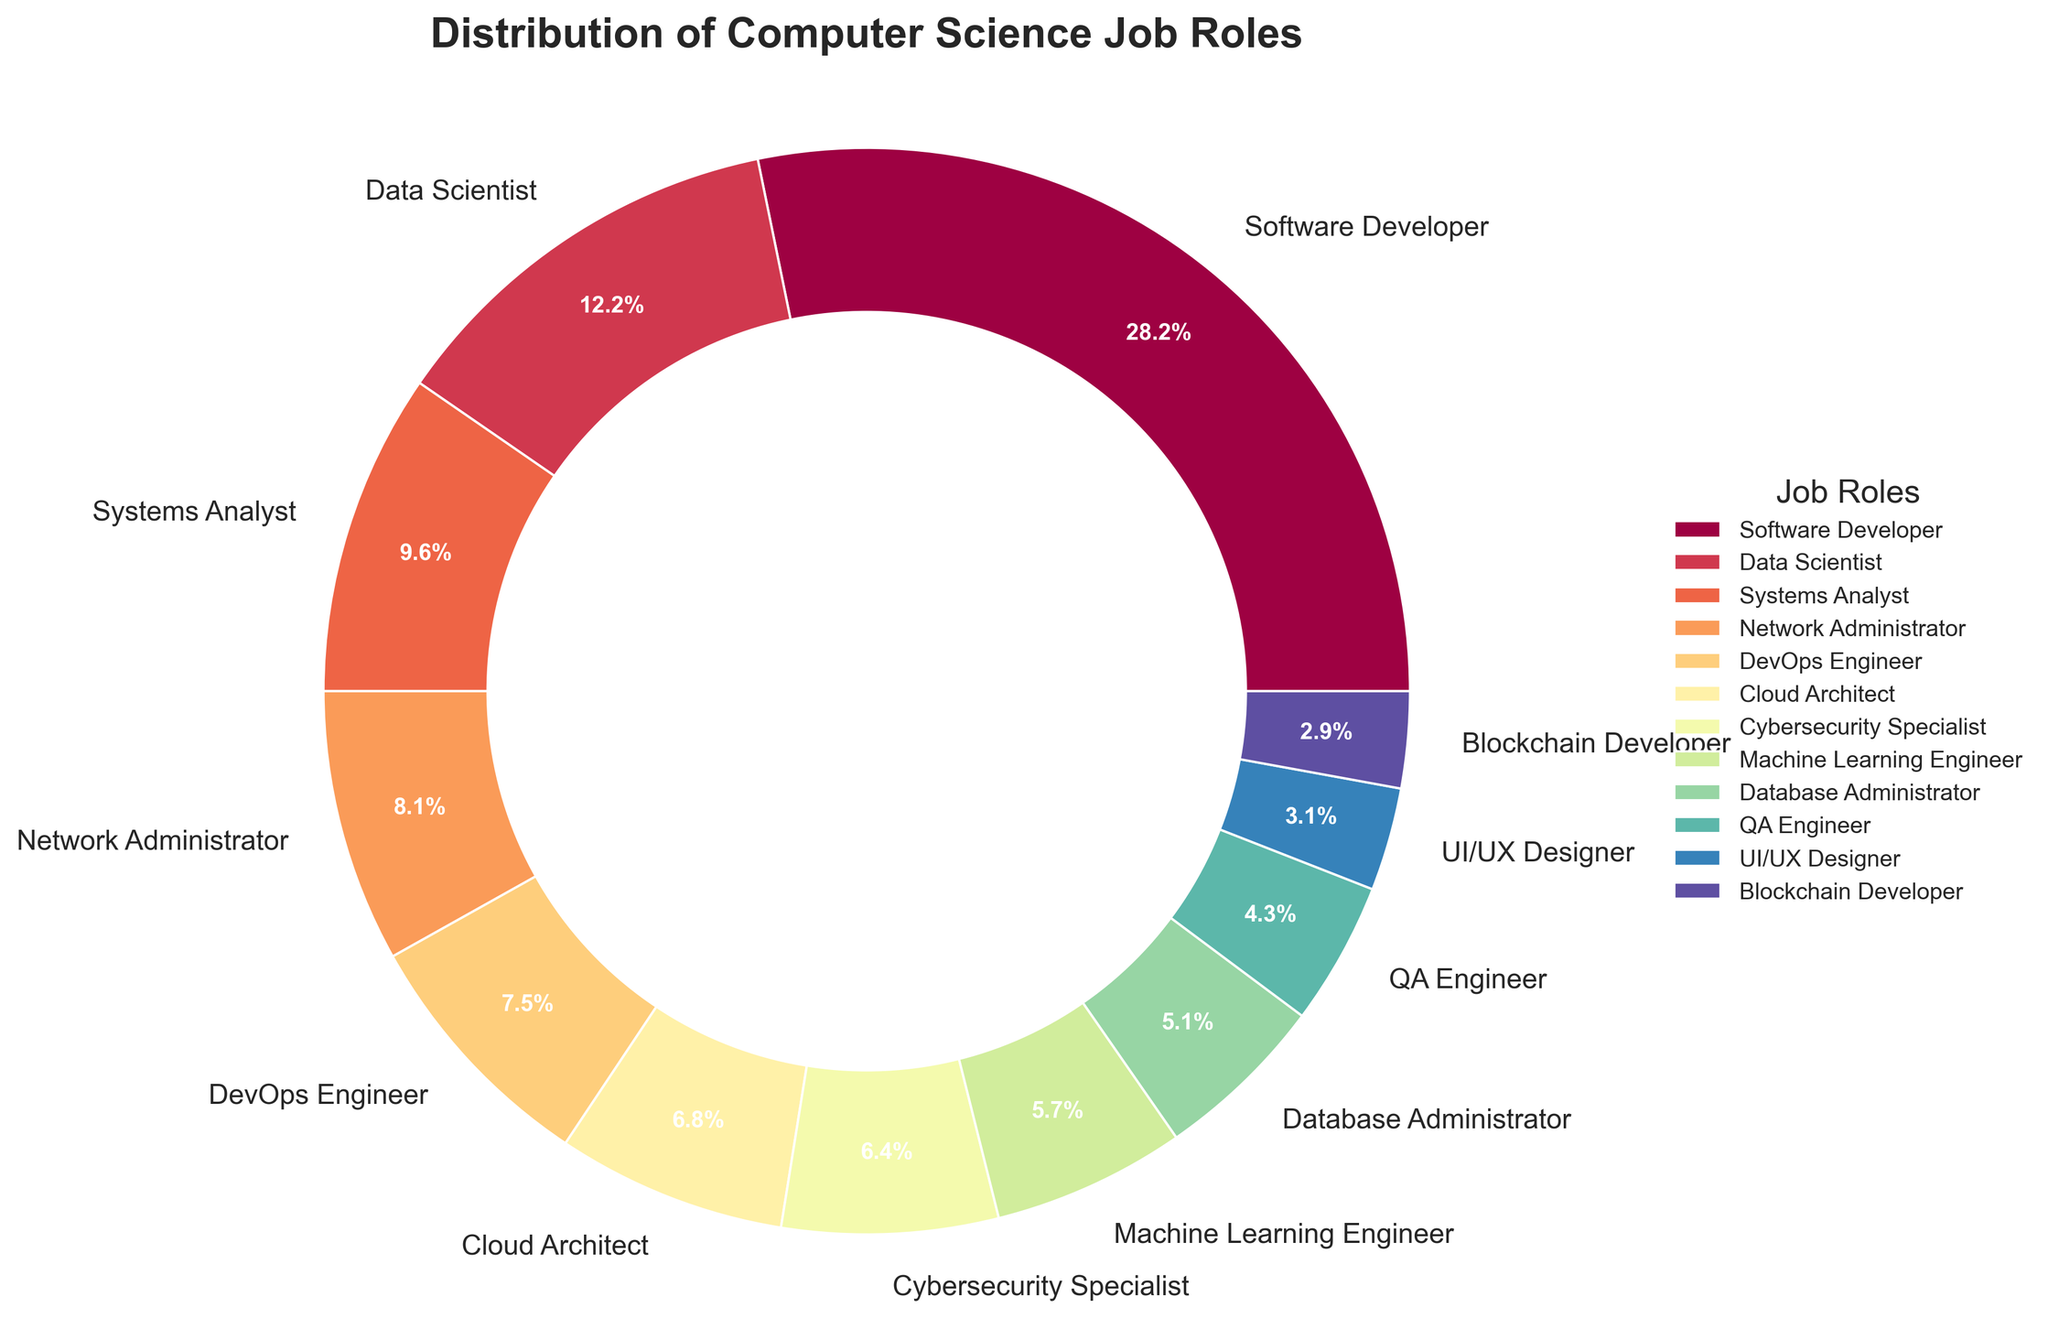What is the most common job role in the distribution? The most common job role can be identified by looking at the slice with the highest percentage. From the pie chart, we see that the Software Developer slice is the largest, labeled as 28.5%.
Answer: Software Developer What is the combined percentage of DevOps Engineers and Cloud Architects? To get the combined percentage, add the percentages of DevOps Engineers (7.6%) and Cloud Architects (6.9%), which are adjacent on the chart.
Answer: 14.5% Which job role has a smaller share, Data Scientist or Systems Analyst? Compare the slices for Data Scientist (12.3%) and Systems Analyst (9.7%) based on their percentages from the pie chart. Systems Analyst has a smaller percentage.
Answer: Systems Analyst Which job role is represented by the light blue color? Identify the job role associated with the light blue slice in the pie chart. The light blue slice matches UI/UX Designer according to its position and percentage label (3.1%).
Answer: UI/UX Designer What is the total percentage of all roles that have less than a 5% share? Sum the percentages of the roles with less than 5%, which are Database Administrator (5.2%), QA Engineer (4.3%), UI/UX Designer (3.1%), and Blockchain Developer (2.9%). Total is 5.2% + 4.3% + 3.1% + 2.9% = 15.5%.
Answer: 15.5% If the percentages for Network Administrators and QA Engineers were combined, would it surpass the percentage of Data Scientists? Combine the percentages of Network Administrators (8.2%) and QA Engineers (4.3%) to get 12.5%. Compare this with the Data Scientist percentage (12.3%). Yes, 12.5% is greater than 12.3%.
Answer: Yes Which job role is exactly half the percentage of Software Developers? Divide the percentage of Software Developers (28.5%) by 2 to get 14.25%. Identify the job role with this percentage. Based on the chart, no single role matches 14.25%, so none is half.
Answer: None How does the proportion of Machine Learning Engineers compare visually to that of Cybersecurity Specialists? Look at the sizes of the slices for Machine Learning Engineers (5.8%) and Cybersecurity Specialists (6.5%). The slice for Cybersecurity Specialists is slightly larger than that for Machine Learning Engineers.
Answer: Cybersecurity Specialist Which job roles combined have a share closest to 20%? Identify job roles and sum their percentages to approximate 20%. For example, Cybersecurity Specialists (6.5%) + Machine Learning Engineer (5.8%) + Database Administrator (5.2%) + UI/UX Designer (3.1%) = 20.6%.
Answer: Cybersecurity Specialist, Machine Learning Engineer, Database Administrator, UI/UX Designer What is the theme style used in generating the pie chart? Observe the overall visual appearance of the chart. The theme style used for the plot is 'seaborn-v0_8-ticks', which provides a clean, tick-based style.
Answer: seaborn-v0_8-ticks 